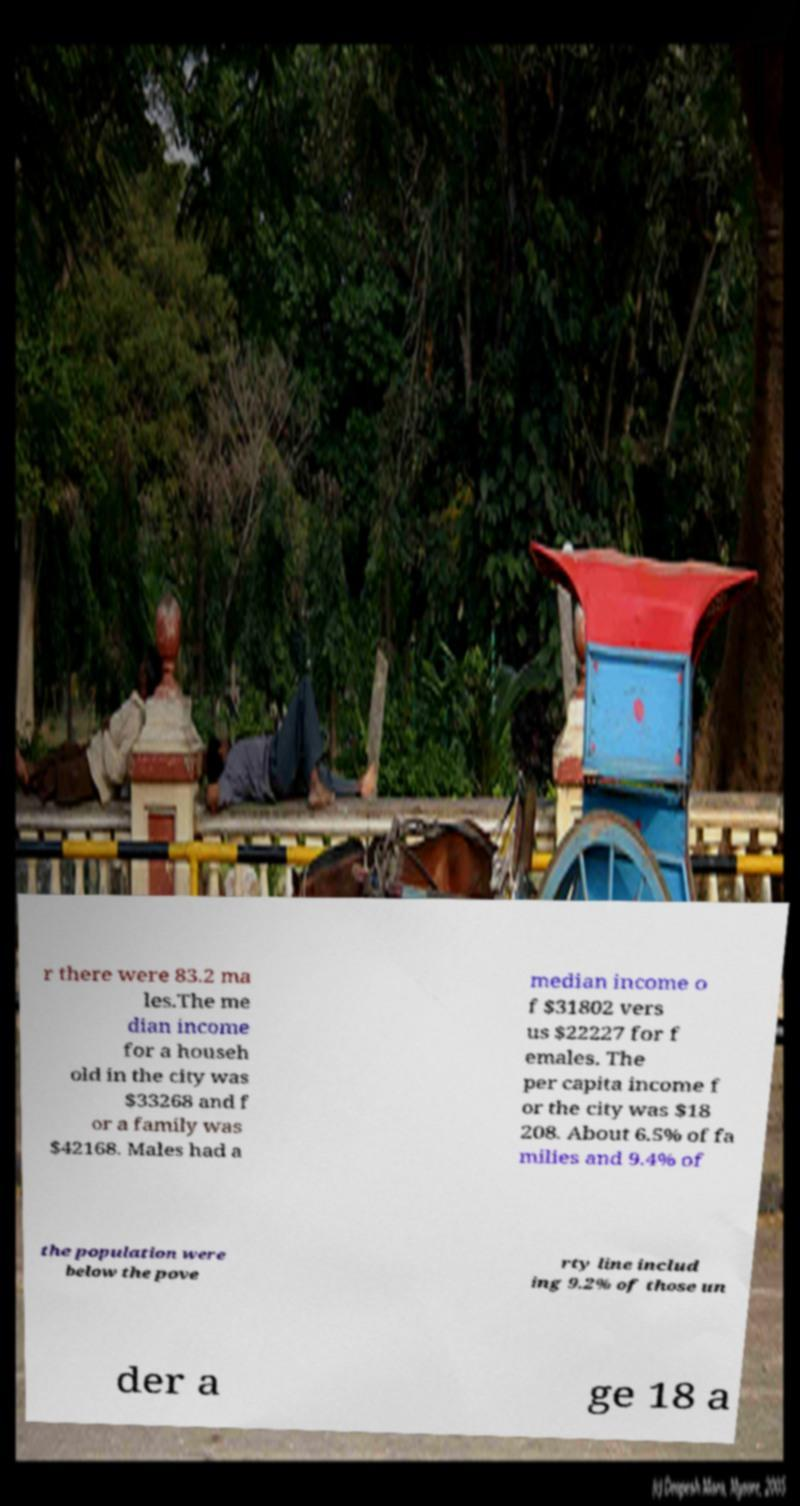Can you accurately transcribe the text from the provided image for me? r there were 83.2 ma les.The me dian income for a househ old in the city was $33268 and f or a family was $42168. Males had a median income o f $31802 vers us $22227 for f emales. The per capita income f or the city was $18 208. About 6.5% of fa milies and 9.4% of the population were below the pove rty line includ ing 9.2% of those un der a ge 18 a 